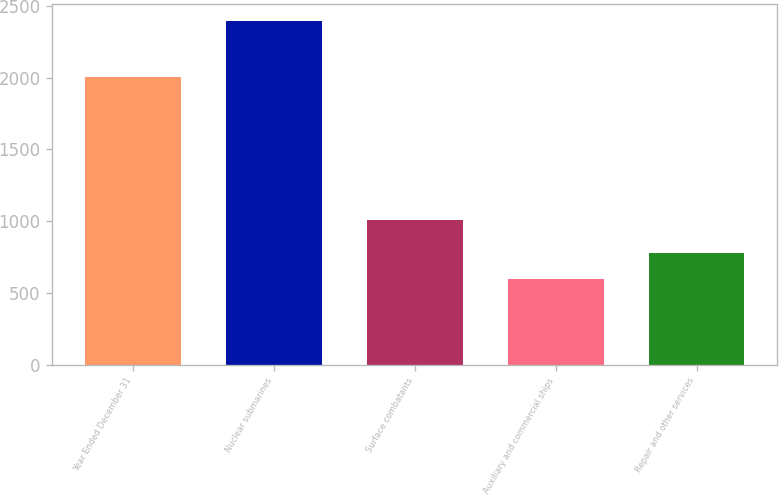Convert chart. <chart><loc_0><loc_0><loc_500><loc_500><bar_chart><fcel>Year Ended December 31<fcel>Nuclear submarines<fcel>Surface combatants<fcel>Auxiliary and commercial ships<fcel>Repair and other services<nl><fcel>2005<fcel>2396<fcel>1008<fcel>598<fcel>777.8<nl></chart> 